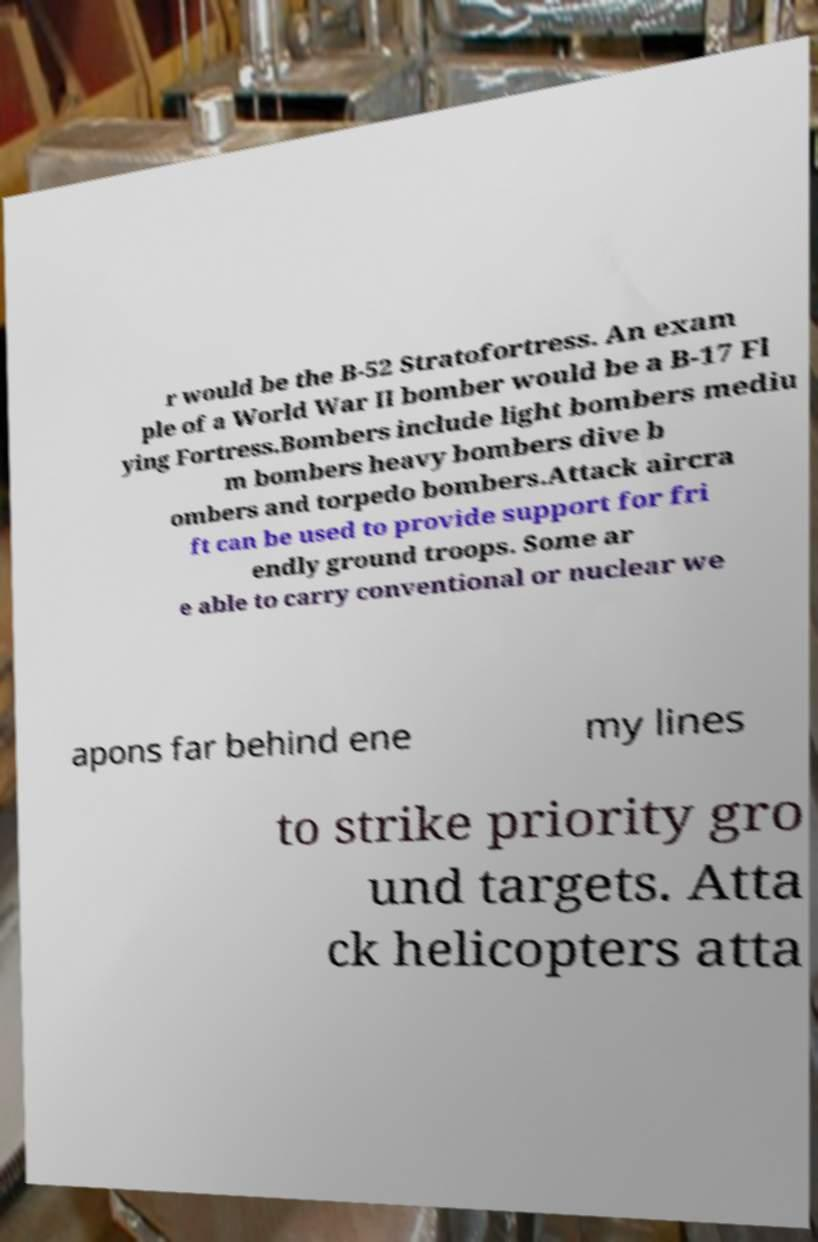Could you extract and type out the text from this image? r would be the B-52 Stratofortress. An exam ple of a World War II bomber would be a B-17 Fl ying Fortress.Bombers include light bombers mediu m bombers heavy bombers dive b ombers and torpedo bombers.Attack aircra ft can be used to provide support for fri endly ground troops. Some ar e able to carry conventional or nuclear we apons far behind ene my lines to strike priority gro und targets. Atta ck helicopters atta 